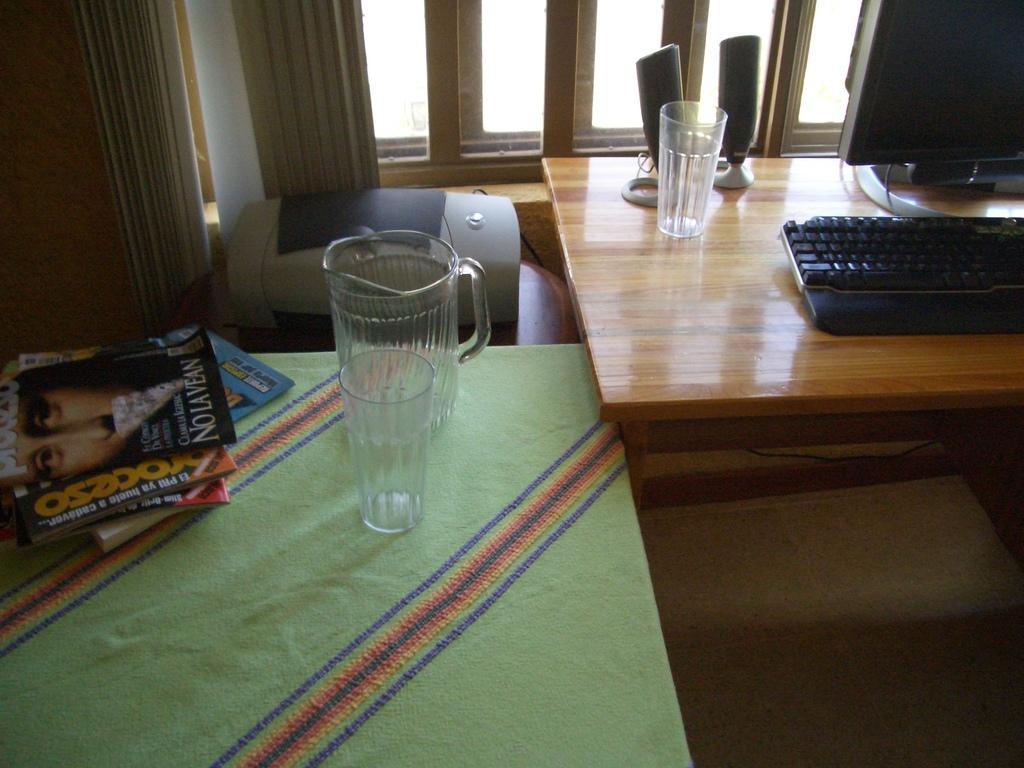Can you describe this image briefly? This is the desk where keyboard,monitor,speakers and tumblr are placed. this is a table covered with green cloth. On this table I can see few books,tumblr,jug and a printer are placed. At background I can see a window with curtains. 